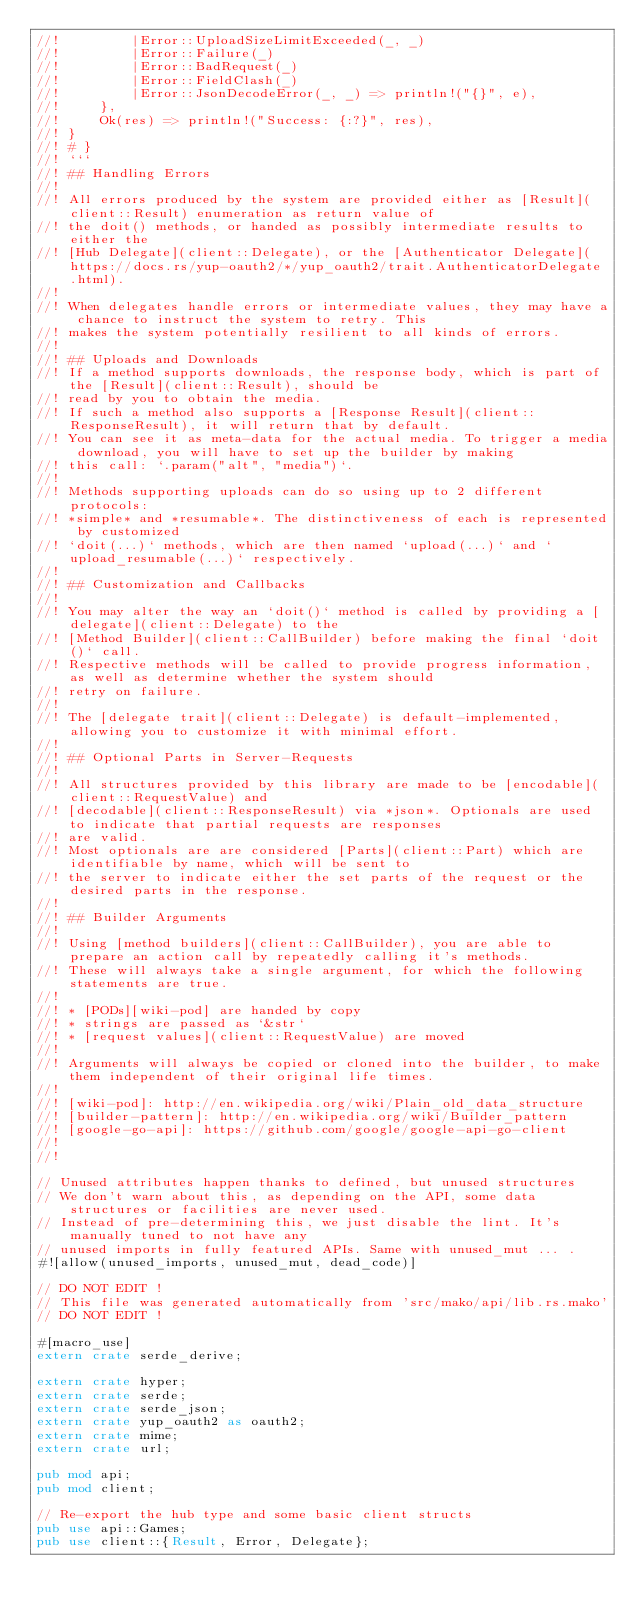Convert code to text. <code><loc_0><loc_0><loc_500><loc_500><_Rust_>//!         |Error::UploadSizeLimitExceeded(_, _)
//!         |Error::Failure(_)
//!         |Error::BadRequest(_)
//!         |Error::FieldClash(_)
//!         |Error::JsonDecodeError(_, _) => println!("{}", e),
//!     },
//!     Ok(res) => println!("Success: {:?}", res),
//! }
//! # }
//! ```
//! ## Handling Errors
//! 
//! All errors produced by the system are provided either as [Result](client::Result) enumeration as return value of
//! the doit() methods, or handed as possibly intermediate results to either the 
//! [Hub Delegate](client::Delegate), or the [Authenticator Delegate](https://docs.rs/yup-oauth2/*/yup_oauth2/trait.AuthenticatorDelegate.html).
//! 
//! When delegates handle errors or intermediate values, they may have a chance to instruct the system to retry. This 
//! makes the system potentially resilient to all kinds of errors.
//! 
//! ## Uploads and Downloads
//! If a method supports downloads, the response body, which is part of the [Result](client::Result), should be
//! read by you to obtain the media.
//! If such a method also supports a [Response Result](client::ResponseResult), it will return that by default.
//! You can see it as meta-data for the actual media. To trigger a media download, you will have to set up the builder by making
//! this call: `.param("alt", "media")`.
//! 
//! Methods supporting uploads can do so using up to 2 different protocols: 
//! *simple* and *resumable*. The distinctiveness of each is represented by customized 
//! `doit(...)` methods, which are then named `upload(...)` and `upload_resumable(...)` respectively.
//! 
//! ## Customization and Callbacks
//! 
//! You may alter the way an `doit()` method is called by providing a [delegate](client::Delegate) to the 
//! [Method Builder](client::CallBuilder) before making the final `doit()` call. 
//! Respective methods will be called to provide progress information, as well as determine whether the system should 
//! retry on failure.
//! 
//! The [delegate trait](client::Delegate) is default-implemented, allowing you to customize it with minimal effort.
//! 
//! ## Optional Parts in Server-Requests
//! 
//! All structures provided by this library are made to be [encodable](client::RequestValue) and 
//! [decodable](client::ResponseResult) via *json*. Optionals are used to indicate that partial requests are responses 
//! are valid.
//! Most optionals are are considered [Parts](client::Part) which are identifiable by name, which will be sent to 
//! the server to indicate either the set parts of the request or the desired parts in the response.
//! 
//! ## Builder Arguments
//! 
//! Using [method builders](client::CallBuilder), you are able to prepare an action call by repeatedly calling it's methods.
//! These will always take a single argument, for which the following statements are true.
//! 
//! * [PODs][wiki-pod] are handed by copy
//! * strings are passed as `&str`
//! * [request values](client::RequestValue) are moved
//! 
//! Arguments will always be copied or cloned into the builder, to make them independent of their original life times.
//! 
//! [wiki-pod]: http://en.wikipedia.org/wiki/Plain_old_data_structure
//! [builder-pattern]: http://en.wikipedia.org/wiki/Builder_pattern
//! [google-go-api]: https://github.com/google/google-api-go-client
//! 
//! 

// Unused attributes happen thanks to defined, but unused structures
// We don't warn about this, as depending on the API, some data structures or facilities are never used.
// Instead of pre-determining this, we just disable the lint. It's manually tuned to not have any
// unused imports in fully featured APIs. Same with unused_mut ... .
#![allow(unused_imports, unused_mut, dead_code)]

// DO NOT EDIT !
// This file was generated automatically from 'src/mako/api/lib.rs.mako'
// DO NOT EDIT !

#[macro_use]
extern crate serde_derive;

extern crate hyper;
extern crate serde;
extern crate serde_json;
extern crate yup_oauth2 as oauth2;
extern crate mime;
extern crate url;

pub mod api;
pub mod client;

// Re-export the hub type and some basic client structs
pub use api::Games;
pub use client::{Result, Error, Delegate};
</code> 